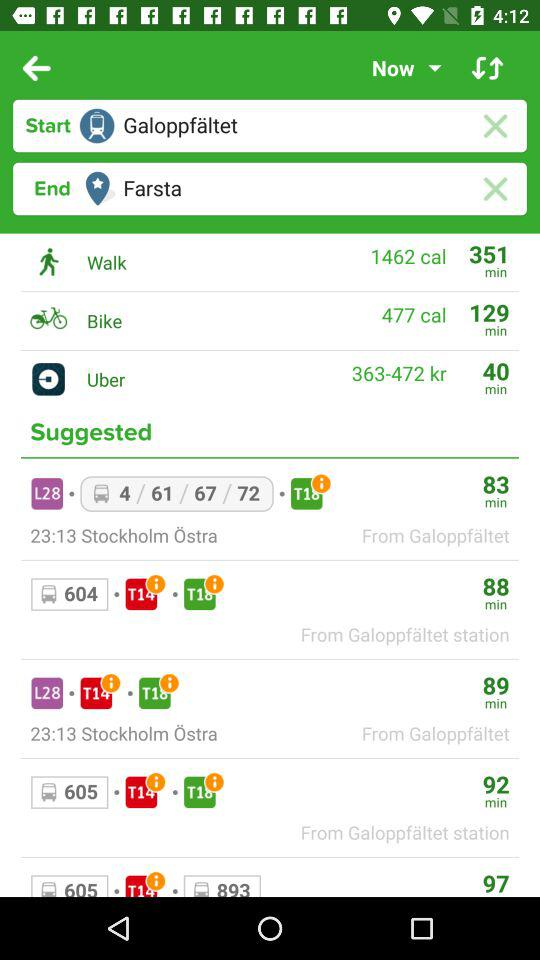How long does it take to walk from Galoppfaltet to Farsta? It takes 351 minutes. 